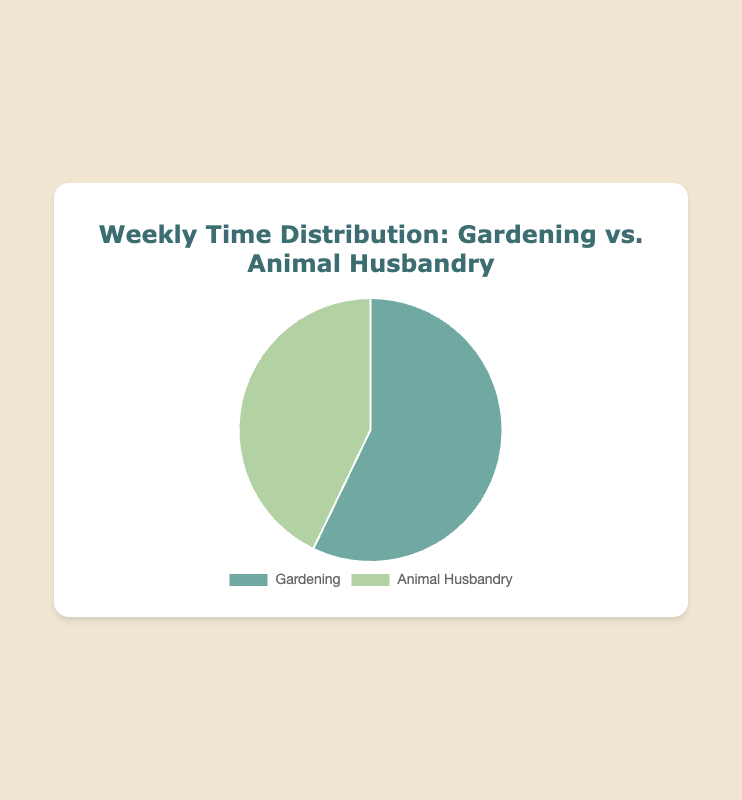Which activity takes up more time weekly, Gardening or Animal Husbandry? According to the pie chart, Gardening takes 20 hours per week, whereas Animal Husbandry takes 15 hours per week.
Answer: Gardening How many more hours per week are spent on Gardening compared to Animal Husbandry? The time spent on Gardening is 20 hours, and on Animal Husbandry is 15 hours. The difference is 20 - 15.
Answer: 5 hours What percentage of the total weekly time is spent on Gardening? The total time spent on both activities is 20 + 15 = 35 hours. The percentage for Gardening is (20/35) * 100.
Answer: ~57.14% What is the ratio of time spent on Gardening to Animal Husbandry? The time spent on Gardening is 20 hours, and on Animal Husbandry is 15 hours. The ratio is 20:15, which simplifies to 4:3.
Answer: 4:3 Which segment in the pie chart has a larger slice, and what color represents it? The pie chart shows time distribution, and the segment for Gardening is larger and colored in a different shade compared to Animal Husbandry. The larger segment for Gardening is indicated by green.
Answer: Gardening, green What is the combined total time spent on Gardening and Animal Husbandry? Adding the time spent on both activities, 20 hours for Gardening and 15 hours for Animal Husbandry.
Answer: 35 hours By how much does the time spent on Animal Husbandry fall short of being equal to Gardening? Gardening requires 20 hours, and Animal Husbandry takes 15 hours. The shortfall is 20 - 15.
Answer: 5 hours If another activity were introduced, requiring 10 hours weekly, what fraction of the total time spent would it represent? With a new activity of 10 hours added, the total becomes 35 + 10 = 45 hours. The fraction for the new activity is 10/45.
Answer: ~22.22% What is the average time spent per week on these two activities? The total time is 35 hours, with two activities involved. The average time is 35/2.
Answer: 17.5 hours 